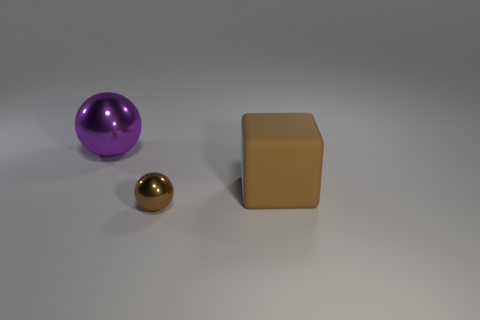Add 2 blue blocks. How many objects exist? 5 Subtract all cubes. How many objects are left? 2 Subtract all big purple spheres. Subtract all small balls. How many objects are left? 1 Add 2 brown things. How many brown things are left? 4 Add 2 tiny gray metal things. How many tiny gray metal things exist? 2 Subtract 1 brown spheres. How many objects are left? 2 